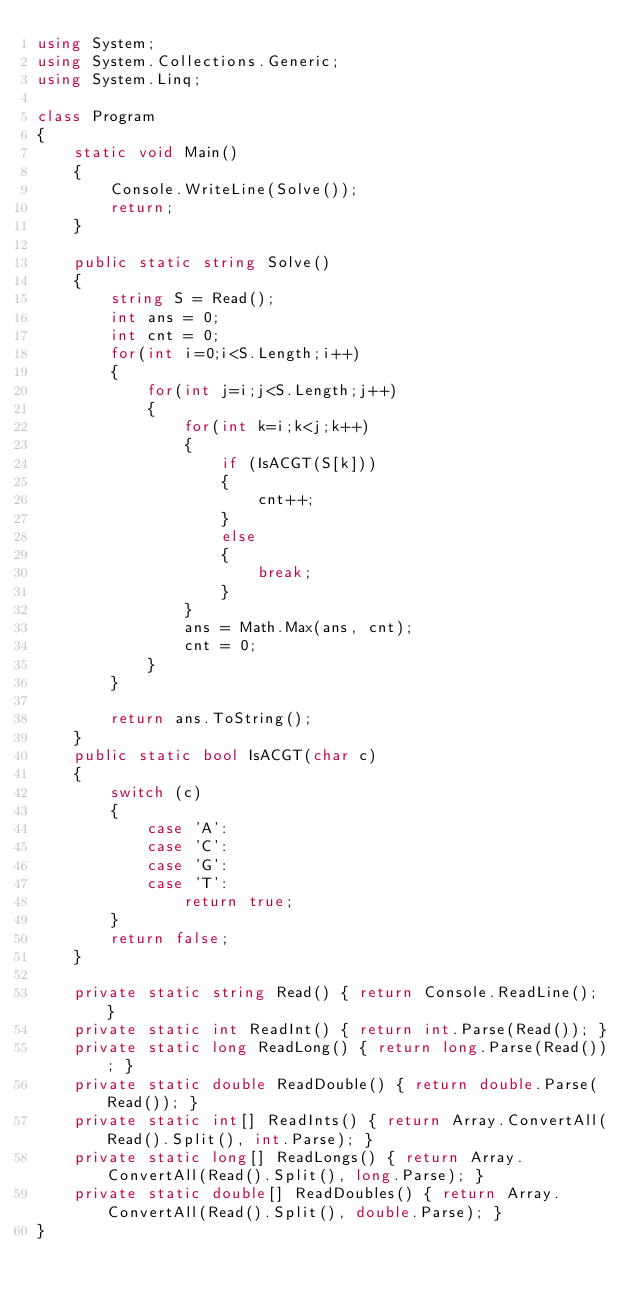<code> <loc_0><loc_0><loc_500><loc_500><_C#_>using System;
using System.Collections.Generic;
using System.Linq;

class Program
{
    static void Main()
    {
        Console.WriteLine(Solve());
        return;
    }

    public static string Solve()
    {
        string S = Read();
        int ans = 0;
        int cnt = 0;
        for(int i=0;i<S.Length;i++)
        {
            for(int j=i;j<S.Length;j++)
            {
                for(int k=i;k<j;k++)
                {
                    if (IsACGT(S[k]))
                    {
                        cnt++;
                    }
                    else
                    {
                        break;
                    }
                }
                ans = Math.Max(ans, cnt);
                cnt = 0;
            }
        }

        return ans.ToString();
    }
    public static bool IsACGT(char c)
    {
        switch (c)
        {
            case 'A':
            case 'C':
            case 'G':
            case 'T':
                return true;
        }
        return false;
    }

    private static string Read() { return Console.ReadLine(); }
    private static int ReadInt() { return int.Parse(Read()); }
    private static long ReadLong() { return long.Parse(Read()); }
    private static double ReadDouble() { return double.Parse(Read()); }
    private static int[] ReadInts() { return Array.ConvertAll(Read().Split(), int.Parse); }
    private static long[] ReadLongs() { return Array.ConvertAll(Read().Split(), long.Parse); }
    private static double[] ReadDoubles() { return Array.ConvertAll(Read().Split(), double.Parse); }
}
</code> 